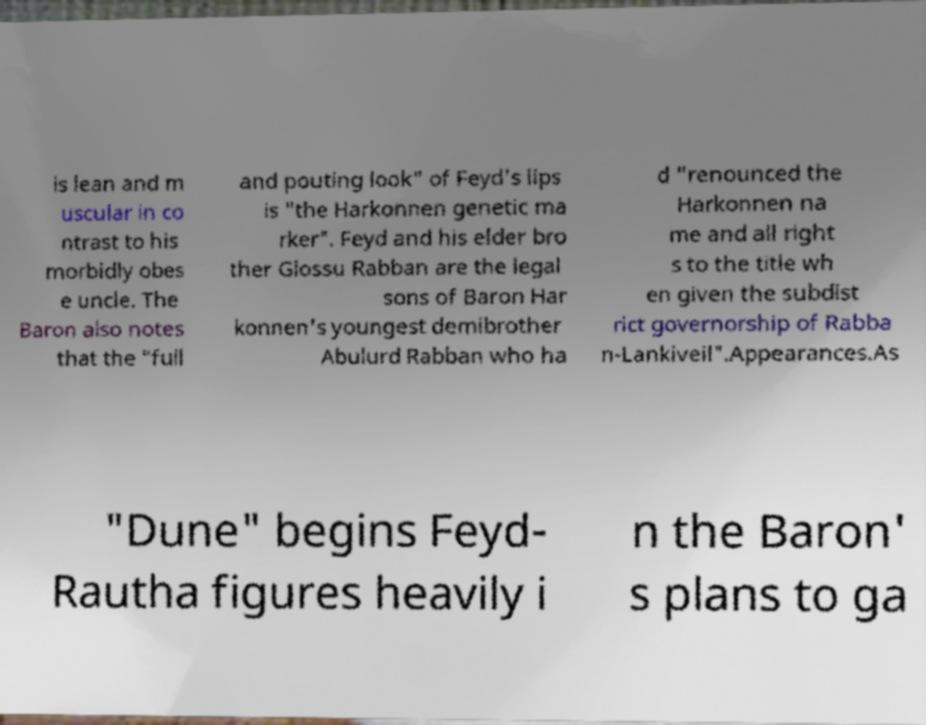What messages or text are displayed in this image? I need them in a readable, typed format. is lean and m uscular in co ntrast to his morbidly obes e uncle. The Baron also notes that the "full and pouting look" of Feyd's lips is "the Harkonnen genetic ma rker". Feyd and his elder bro ther Glossu Rabban are the legal sons of Baron Har konnen's youngest demibrother Abulurd Rabban who ha d "renounced the Harkonnen na me and all right s to the title wh en given the subdist rict governorship of Rabba n-Lankiveil".Appearances.As "Dune" begins Feyd- Rautha figures heavily i n the Baron' s plans to ga 